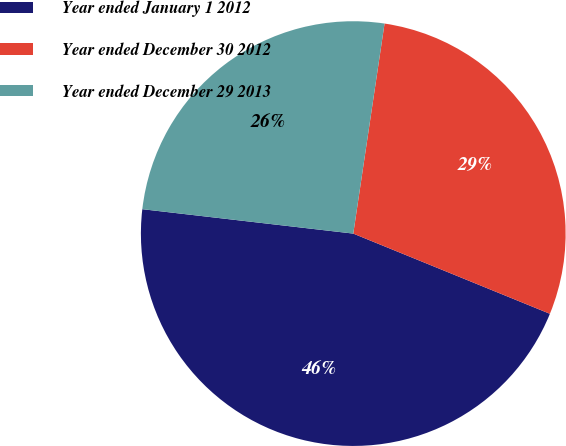Convert chart to OTSL. <chart><loc_0><loc_0><loc_500><loc_500><pie_chart><fcel>Year ended January 1 2012<fcel>Year ended December 30 2012<fcel>Year ended December 29 2013<nl><fcel>45.67%<fcel>28.81%<fcel>25.52%<nl></chart> 